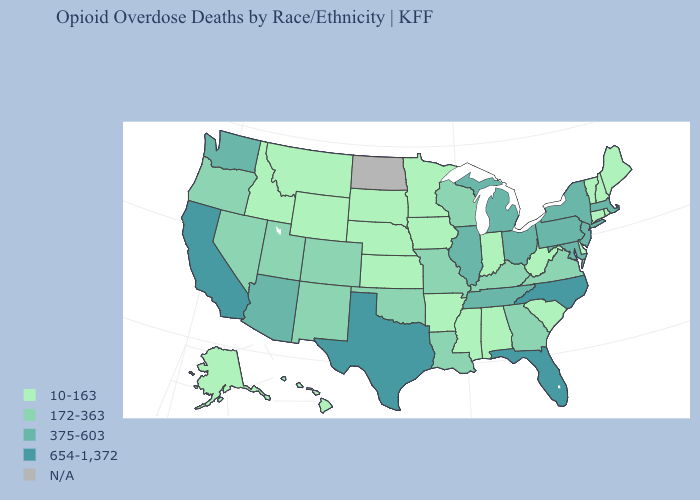How many symbols are there in the legend?
Write a very short answer. 5. Which states have the highest value in the USA?
Quick response, please. California, Florida, North Carolina, Texas. Which states hav the highest value in the South?
Keep it brief. Florida, North Carolina, Texas. Which states have the lowest value in the USA?
Write a very short answer. Alabama, Alaska, Arkansas, Connecticut, Delaware, Hawaii, Idaho, Indiana, Iowa, Kansas, Maine, Minnesota, Mississippi, Montana, Nebraska, New Hampshire, Rhode Island, South Carolina, South Dakota, Vermont, West Virginia, Wyoming. Which states hav the highest value in the South?
Give a very brief answer. Florida, North Carolina, Texas. Does the map have missing data?
Short answer required. Yes. What is the lowest value in the South?
Short answer required. 10-163. Name the states that have a value in the range 375-603?
Concise answer only. Arizona, Illinois, Maryland, Massachusetts, Michigan, New Jersey, New York, Ohio, Pennsylvania, Tennessee, Washington. Name the states that have a value in the range 375-603?
Short answer required. Arizona, Illinois, Maryland, Massachusetts, Michigan, New Jersey, New York, Ohio, Pennsylvania, Tennessee, Washington. Does the first symbol in the legend represent the smallest category?
Give a very brief answer. Yes. What is the lowest value in states that border Kansas?
Give a very brief answer. 10-163. What is the highest value in the USA?
Short answer required. 654-1,372. Does the first symbol in the legend represent the smallest category?
Keep it brief. Yes. What is the highest value in the USA?
Answer briefly. 654-1,372. 